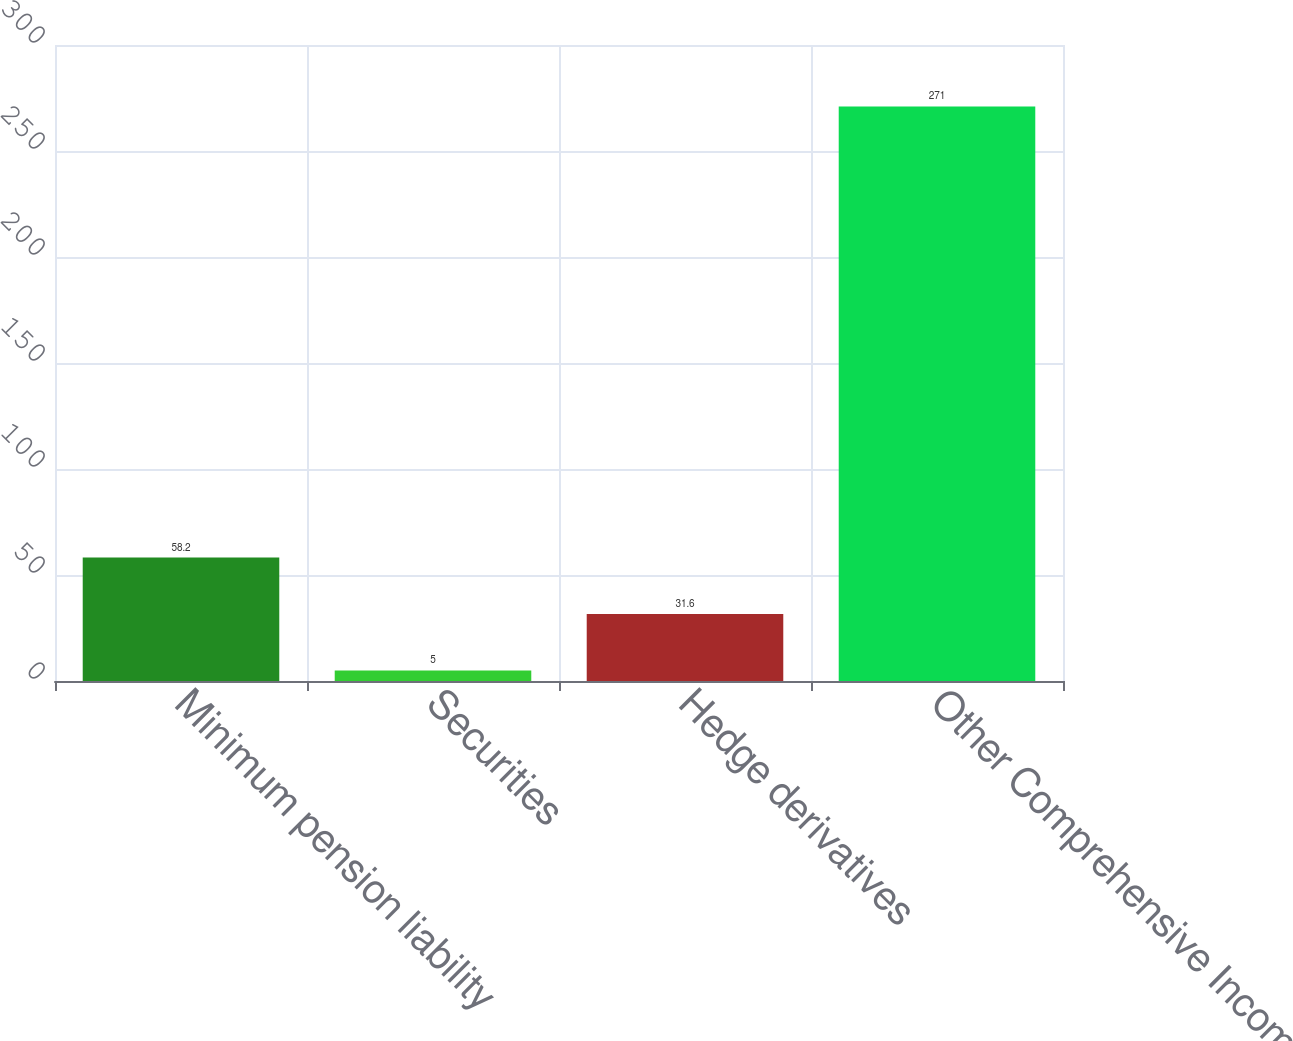Convert chart to OTSL. <chart><loc_0><loc_0><loc_500><loc_500><bar_chart><fcel>Minimum pension liability<fcel>Securities<fcel>Hedge derivatives<fcel>Other Comprehensive Income<nl><fcel>58.2<fcel>5<fcel>31.6<fcel>271<nl></chart> 